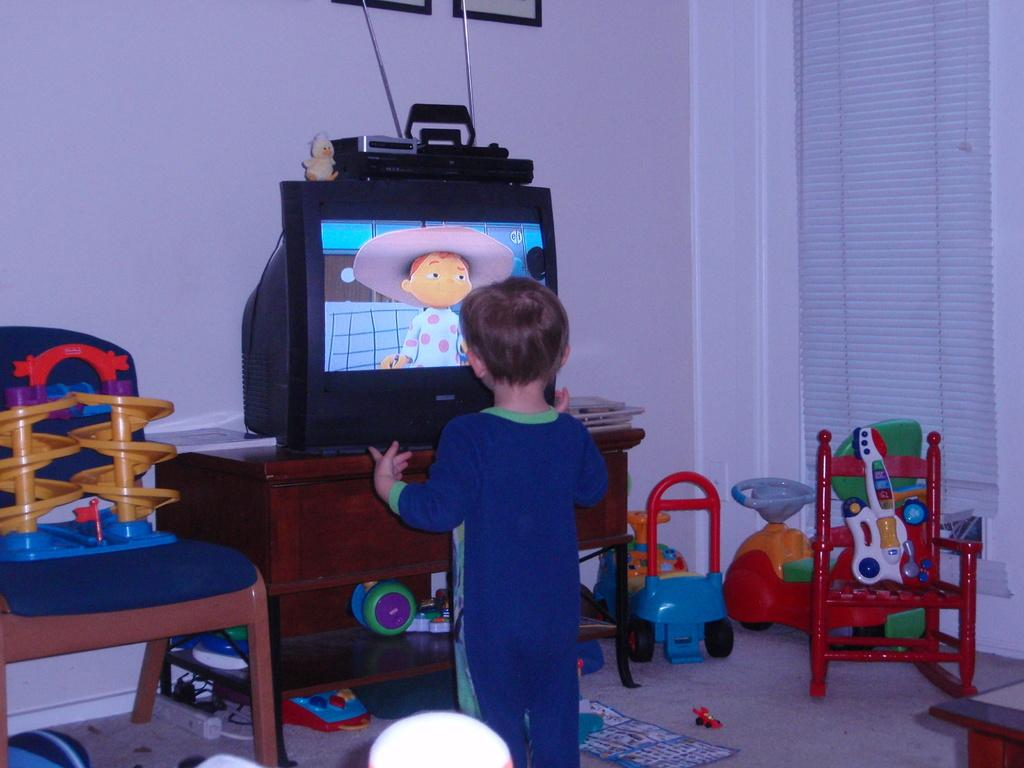Who is the main subject in the image? There is a little boy in the image. What is the boy doing in the image? The boy is standing in front of a table. What object is on the table in the image? There is a television on the table. What else can be seen on the floor around the table? Toys are placed on the floor around the table. What type of veil is draped over the television in the image? There is no veil draped over the television in the image. The television is simply sitting on the table. What belief system does the little boy follow, as depicted in the image? The image does not provide any information about the little boy's belief system. 